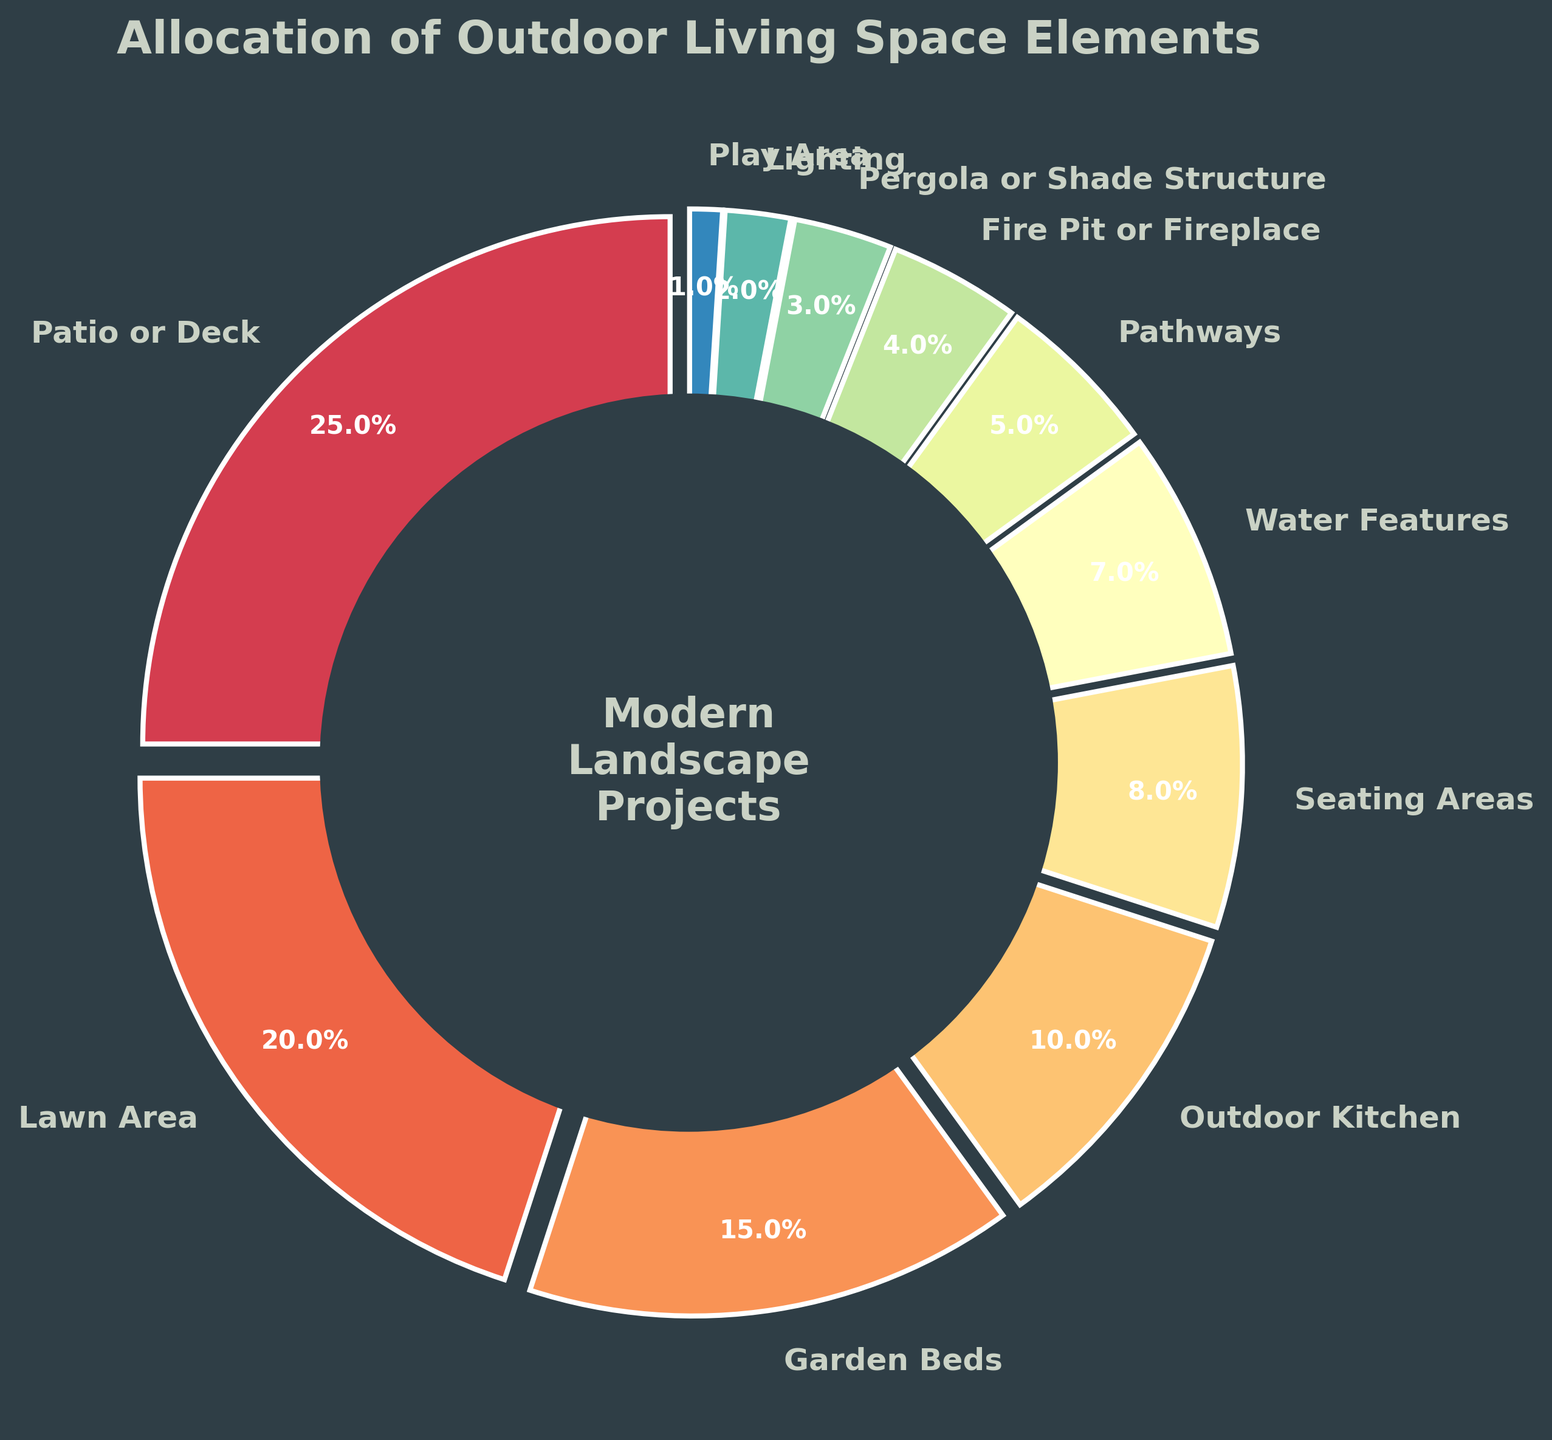What's the largest outdoor living space element in the chart? The largest element can be identified by looking at the segment of the pie chart that occupies the largest area. "Patio or Deck" covers the largest area in the pie chart.
Answer: Patio or Deck What is the combined percentage for Lawn Area and Garden Beds? Locate the segments labeled "Lawn Area" and "Garden Beds" and add their percentages. Lawn Area is 20% and Garden Beds is 15%, so combined it's 20% + 15% = 35%.
Answer: 35% Which element has a percentage closest to the Outdoor Kitchen? Identify the percentage for Outdoor Kitchen, which is 10%. Then, look for the element with the percentage closest to this value. Seating Areas is 8%, making it the closest.
Answer: Seating Areas How much more percentage does Patio or Deck have compared to Lawn Area? Find the percentages for Patio or Deck and Lawn Area. Patio or Deck is 25% and Lawn Area is 20%. Subtracting the two gives 25% - 20% = 5%.
Answer: 5% Which elements together make up less than 10% of the living space each? Identify the segments that are less than 10%: Pathways (5%), Fire Pit or Fireplace (4%), Pergola or Shade Structure (3%), Lighting (2%), Play Area (1%).
Answer: Pathways, Fire Pit or Fireplace, Pergola or Shade Structure, Lighting, Play Area What percentage is represented by the smallest section of the pie chart? Look at the segments and identify the smallest one visually. The smallest section is "Play Area," which is 1%.
Answer: 1% Which is larger: Water Features or Seating Areas, and by how much? Compare the percentages of Water Features (7%) and Seating Areas (8%). Seating Areas is larger by 8% - 7% = 1%.
Answer: Seating Areas by 1% What are the top three elements that occupy the largest portions of the outdoor living space? Determine the segments with the highest percentages. The top three are Patio or Deck (25%), Lawn Area (20%), and Garden Beds (15%).
Answer: Patio or Deck, Lawn Area, Garden Beds What’s the average percentage allocation of Fire Pit or Fireplace, Pergola or Shade Structure, and Lighting? Find the percentages for these elements: Fire Pit or Fireplace (4%), Pergola or Shade Structure (3%), Lighting (2%). Add them together and divide by the number of elements: (4% + 3% + 2%) / 3 = 9% / 3 = 3%.
Answer: 3% If you combined Patio or Deck, Lawn Area, and Outdoor Kitchen, what percentage of the total space would that be? Add the percentages of Patio or Deck (25%), Lawn Area (20%), and Outdoor Kitchen (10%). 25% + 20% + 10% = 55%.
Answer: 55% 